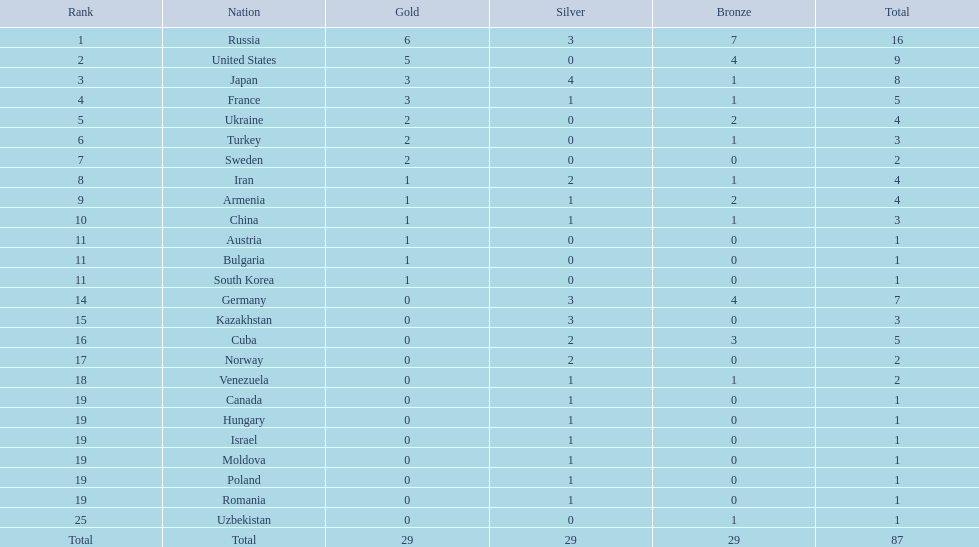How many combined gold medals did japan and france win? 6. 